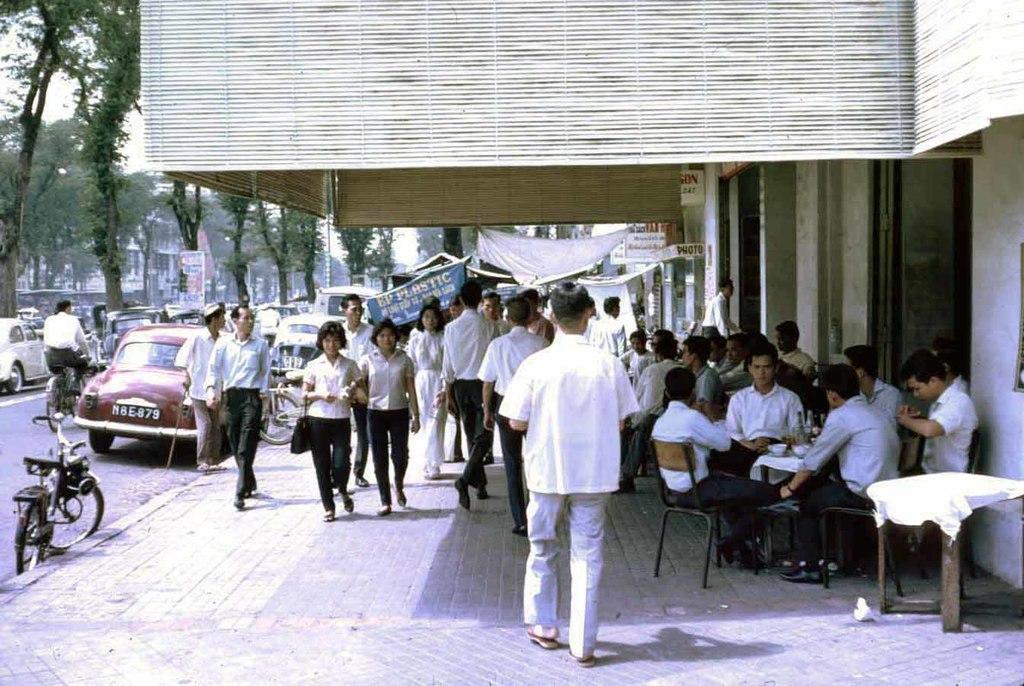How would you summarize this image in a sentence or two? In this picture we can see some persons are walking on the road. There is a bicycle and these are vehicles. Here we can see some persons are sitting on the chairs. These are the trees and there is a building. 